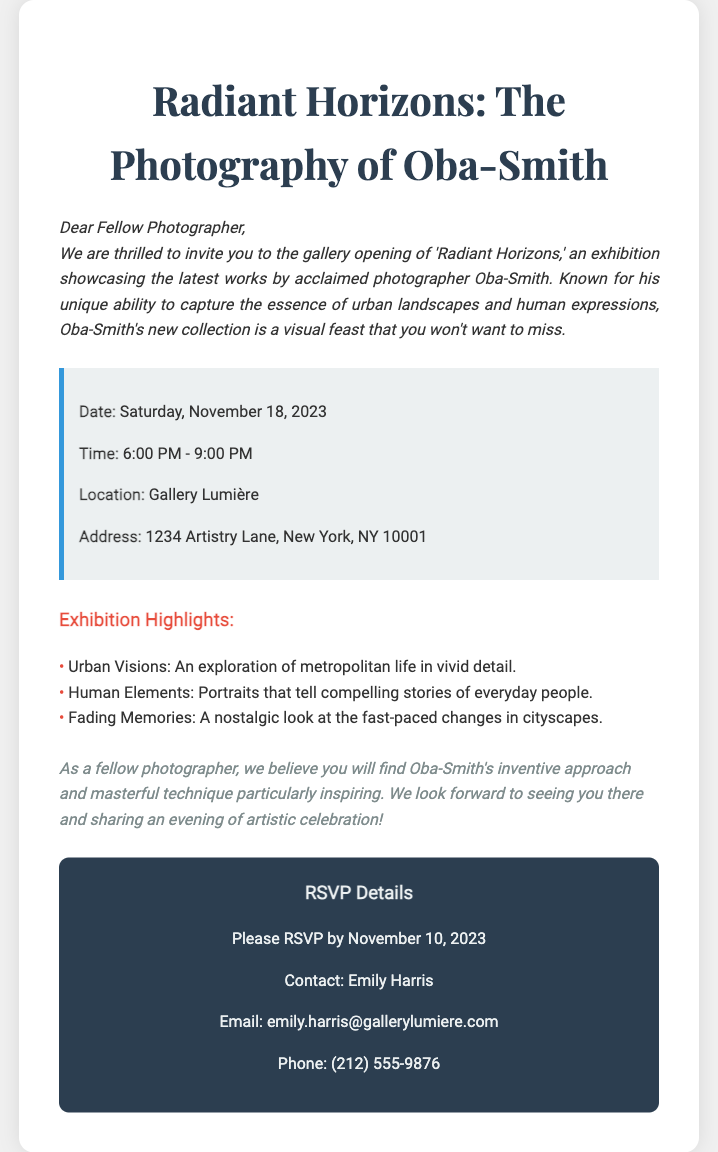What is the date of the gallery opening? The date is specified in the event details section of the document.
Answer: Saturday, November 18, 2023 What is the start time of the exhibition? The start time is listed in the event details section of the document.
Answer: 6:00 PM What is the address of Gallery Lumière? The address is provided in the event details part.
Answer: 1234 Artistry Lane, New York, NY 10001 Who should be contacted for RSVP? Contact information is given in the RSVP details section of the document.
Answer: Emily Harris By what date must one RSVP? The RSVP deadline is mentioned clearly in the RSVP details.
Answer: November 10, 2023 What is the main theme of the exhibition? The overall theme can be inferred from the title of the exhibition and the highlights provided.
Answer: Radiant Horizons What does the phrase “Fading Memories” refer to? "Fading Memories" is a title of one of the highlights indicating a specific theme explored in the exhibition.
Answer: A nostalgic look at the fast-paced changes in cityscapes What is the time duration of the exhibition? The duration is derived from the start and end times mentioned.
Answer: 3 hours What style of photography is highlighted in Oba-Smith's work? The document details the photography style and themes being explored in the exhibition.
Answer: Urban landscapes and human expressions 